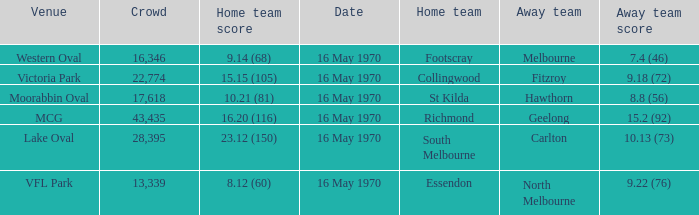Can you parse all the data within this table? {'header': ['Venue', 'Crowd', 'Home team score', 'Date', 'Home team', 'Away team', 'Away team score'], 'rows': [['Western Oval', '16,346', '9.14 (68)', '16 May 1970', 'Footscray', 'Melbourne', '7.4 (46)'], ['Victoria Park', '22,774', '15.15 (105)', '16 May 1970', 'Collingwood', 'Fitzroy', '9.18 (72)'], ['Moorabbin Oval', '17,618', '10.21 (81)', '16 May 1970', 'St Kilda', 'Hawthorn', '8.8 (56)'], ['MCG', '43,435', '16.20 (116)', '16 May 1970', 'Richmond', 'Geelong', '15.2 (92)'], ['Lake Oval', '28,395', '23.12 (150)', '16 May 1970', 'South Melbourne', 'Carlton', '10.13 (73)'], ['VFL Park', '13,339', '8.12 (60)', '16 May 1970', 'Essendon', 'North Melbourne', '9.22 (76)']]} Who was the away team at western oval? Melbourne. 